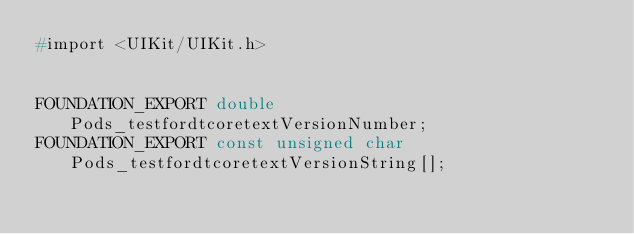<code> <loc_0><loc_0><loc_500><loc_500><_C_>#import <UIKit/UIKit.h>


FOUNDATION_EXPORT double Pods_testfordtcoretextVersionNumber;
FOUNDATION_EXPORT const unsigned char Pods_testfordtcoretextVersionString[];

</code> 